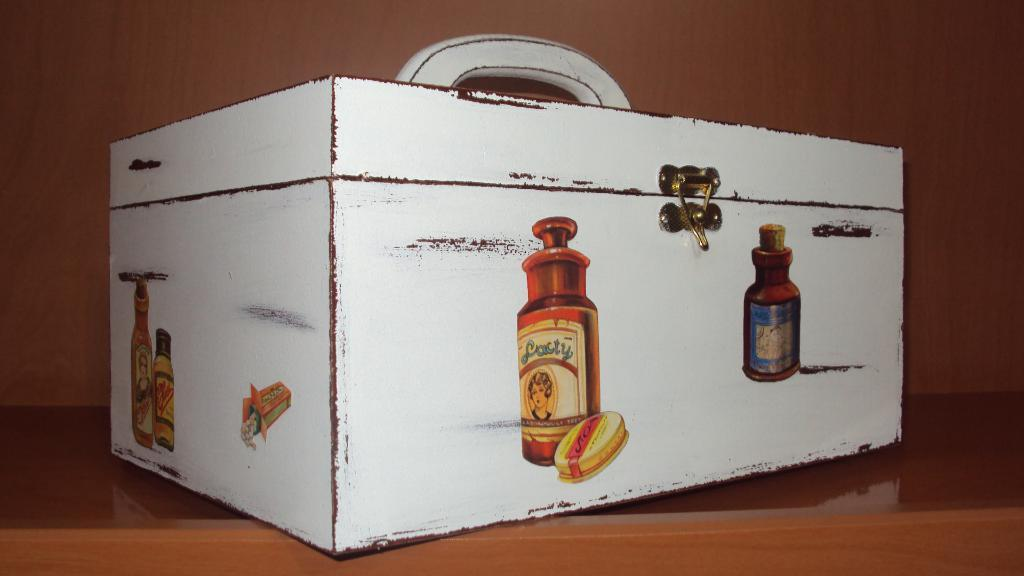What is the main object in the image? There is a box in the image. What color is the box? The box is painted white. Are there any designs or images on the box? Yes, there are images on the box. What type of surface is the box placed on? The box is placed on a wooden floor. Can you see a rifle leaning against the box in the image? No, there is no rifle present in the image. 